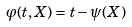Convert formula to latex. <formula><loc_0><loc_0><loc_500><loc_500>\varphi ( t , X ) = t - \psi ( X )</formula> 